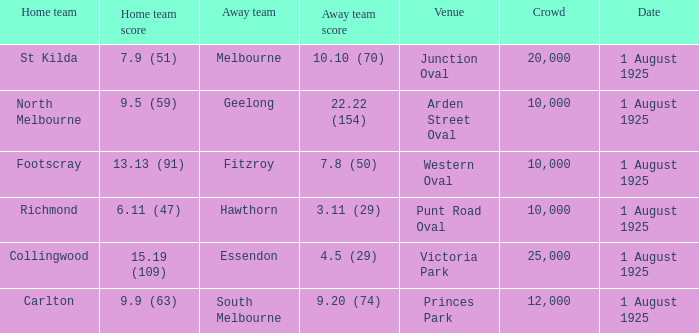Of matches that had a home team score of 13.13 (91), which one had the largest crowd? 10000.0. 